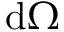<formula> <loc_0><loc_0><loc_500><loc_500>d \Omega</formula> 